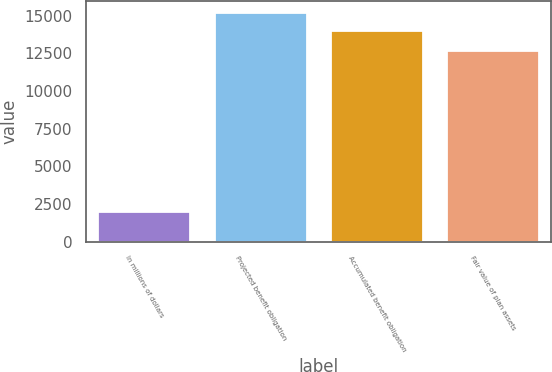<chart> <loc_0><loc_0><loc_500><loc_500><bar_chart><fcel>In millions of dollars<fcel>Projected benefit obligation<fcel>Accumulated benefit obligation<fcel>Fair value of plan assets<nl><fcel>2017<fcel>15236.3<fcel>14034<fcel>12725<nl></chart> 